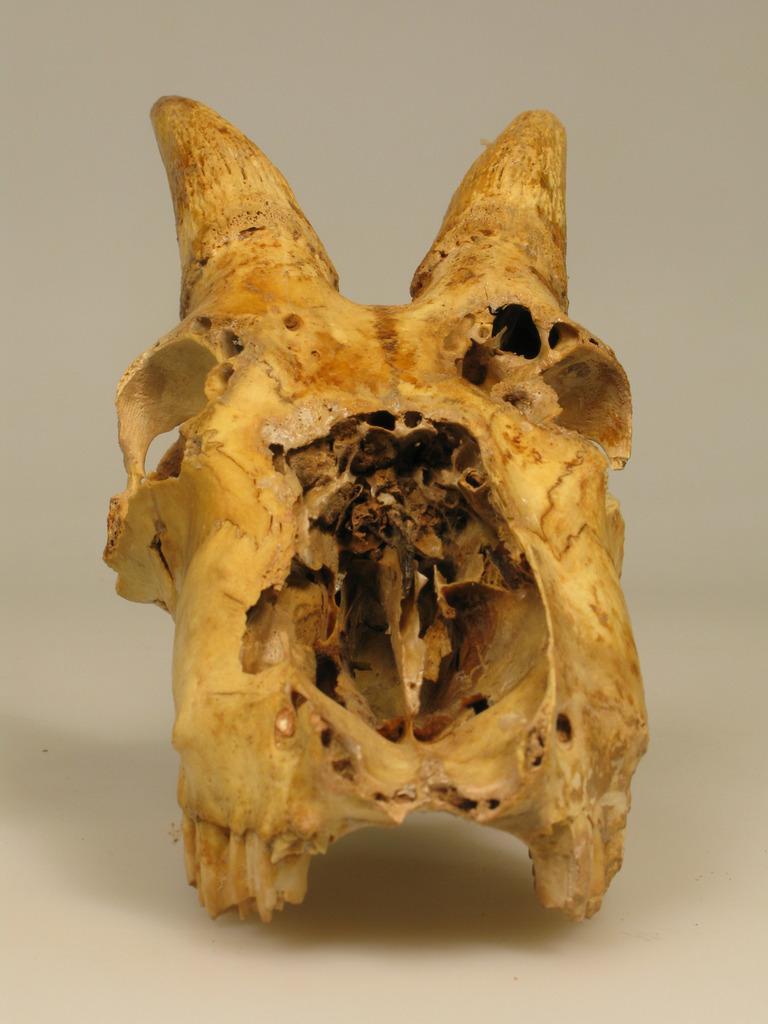Could you give a brief overview of what you see in this image? In this image we can see an object which looks like a skull. 